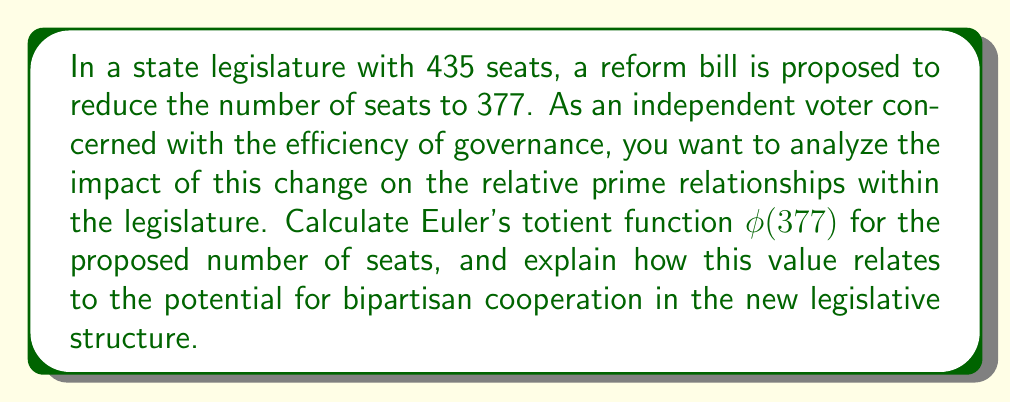What is the answer to this math problem? To calculate Euler's totient function $\phi(377)$, we follow these steps:

1) First, we need to find the prime factorization of 377:
   $377 = 13 \times 29$

2) For a prime number $p$, the value of $\phi(p)$ is $p - 1$.

3) For a product of two distinct primes $p$ and $q$, the formula is:
   $\phi(pq) = \phi(p) \times \phi(q) = (p-1)(q-1)$

4) Applying this to our case:
   $\phi(377) = \phi(13) \times \phi(29) = (13-1)(29-1) = 12 \times 28$

5) Calculating the final result:
   $\phi(377) = 12 \times 28 = 336$

The value 336 represents the number of positive integers up to 377 that are coprime to 377. In the context of legislative seats, this could be interpreted as the number of potential voting blocs or coalitions that could form with a relative prime relationship to the total number of seats. A higher value suggests more opportunities for diverse alliances and bipartisan cooperation, as there are more ways to form groups that don't share common factors with the total, potentially reducing the likelihood of the legislature being dominated by a few large factions.
Answer: $\phi(377) = 336$ 